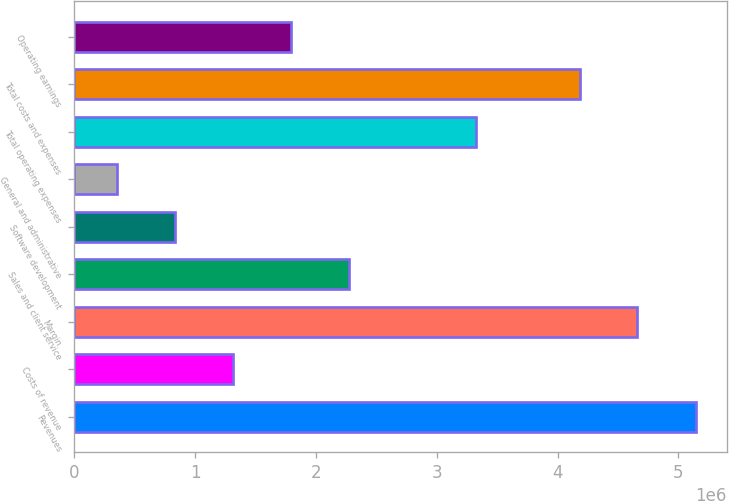Convert chart to OTSL. <chart><loc_0><loc_0><loc_500><loc_500><bar_chart><fcel>Revenues<fcel>Costs of revenue<fcel>Margin<fcel>Sales and client service<fcel>Software development<fcel>General and administrative<fcel>Total operating expenses<fcel>Total costs and expenses<fcel>Operating earnings<nl><fcel>5.14227e+06<fcel>1.31267e+06<fcel>4.6605e+06<fcel>2.27682e+06<fcel>833968<fcel>355267<fcel>3.32771e+06<fcel>4.1818e+06<fcel>1.79137e+06<nl></chart> 